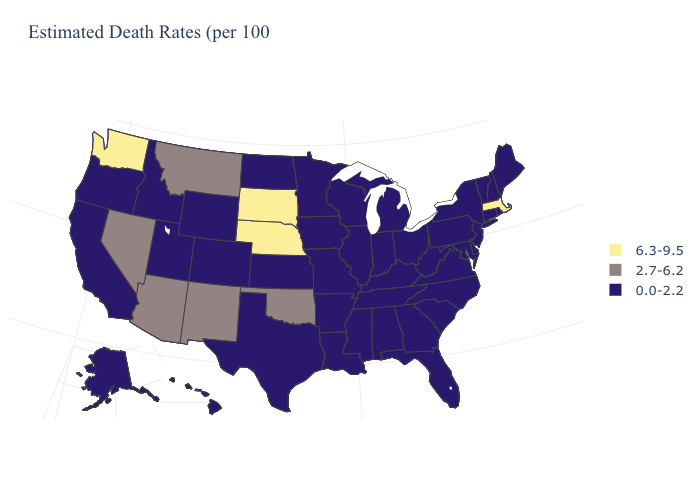Is the legend a continuous bar?
Keep it brief. No. Name the states that have a value in the range 2.7-6.2?
Be succinct. Arizona, Montana, Nevada, New Mexico, Oklahoma. Name the states that have a value in the range 2.7-6.2?
Write a very short answer. Arizona, Montana, Nevada, New Mexico, Oklahoma. Does Washington have the highest value in the USA?
Be succinct. Yes. Name the states that have a value in the range 6.3-9.5?
Give a very brief answer. Massachusetts, Nebraska, South Dakota, Washington. Does Washington have the highest value in the West?
Answer briefly. Yes. Among the states that border Idaho , which have the highest value?
Keep it brief. Washington. What is the highest value in states that border Maryland?
Keep it brief. 0.0-2.2. Among the states that border Connecticut , does New York have the highest value?
Concise answer only. No. Does Montana have the lowest value in the USA?
Short answer required. No. Which states have the highest value in the USA?
Concise answer only. Massachusetts, Nebraska, South Dakota, Washington. Does Mississippi have the same value as Kansas?
Concise answer only. Yes. Does Massachusetts have a higher value than Wisconsin?
Answer briefly. Yes. What is the lowest value in states that border Michigan?
Answer briefly. 0.0-2.2. 